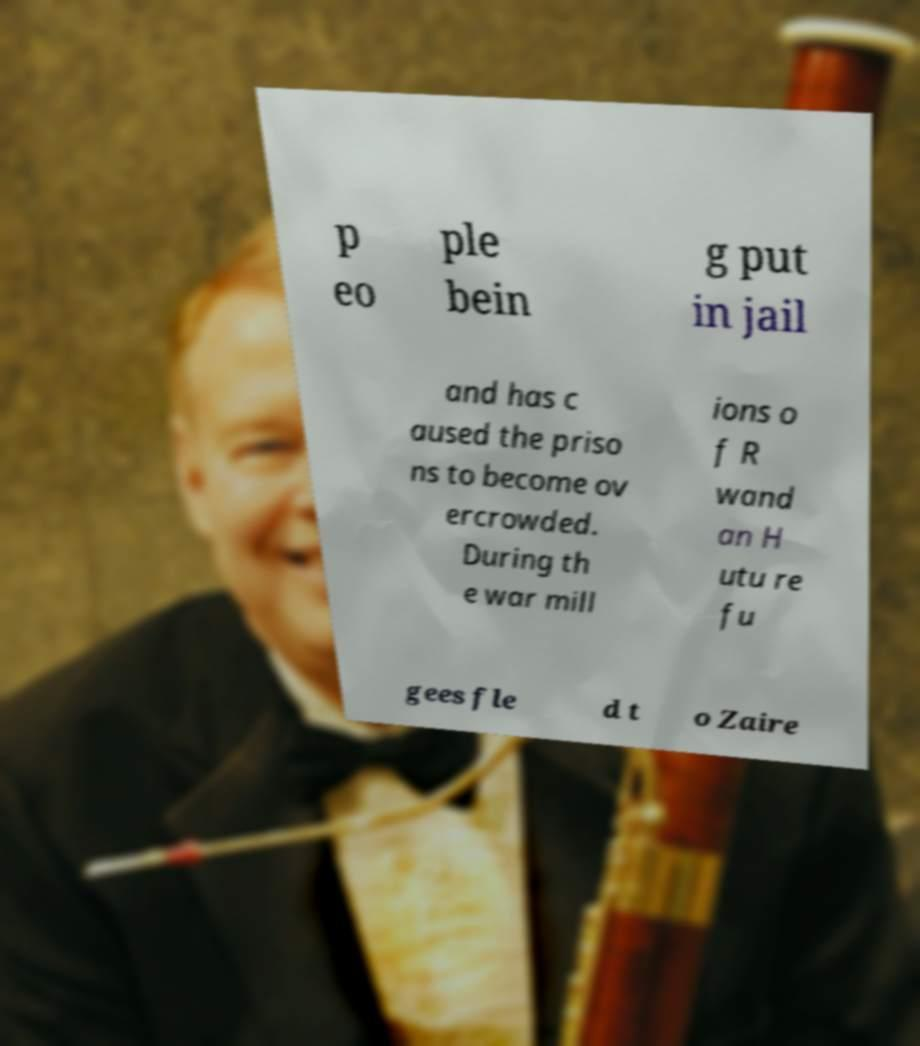What messages or text are displayed in this image? I need them in a readable, typed format. p eo ple bein g put in jail and has c aused the priso ns to become ov ercrowded. During th e war mill ions o f R wand an H utu re fu gees fle d t o Zaire 